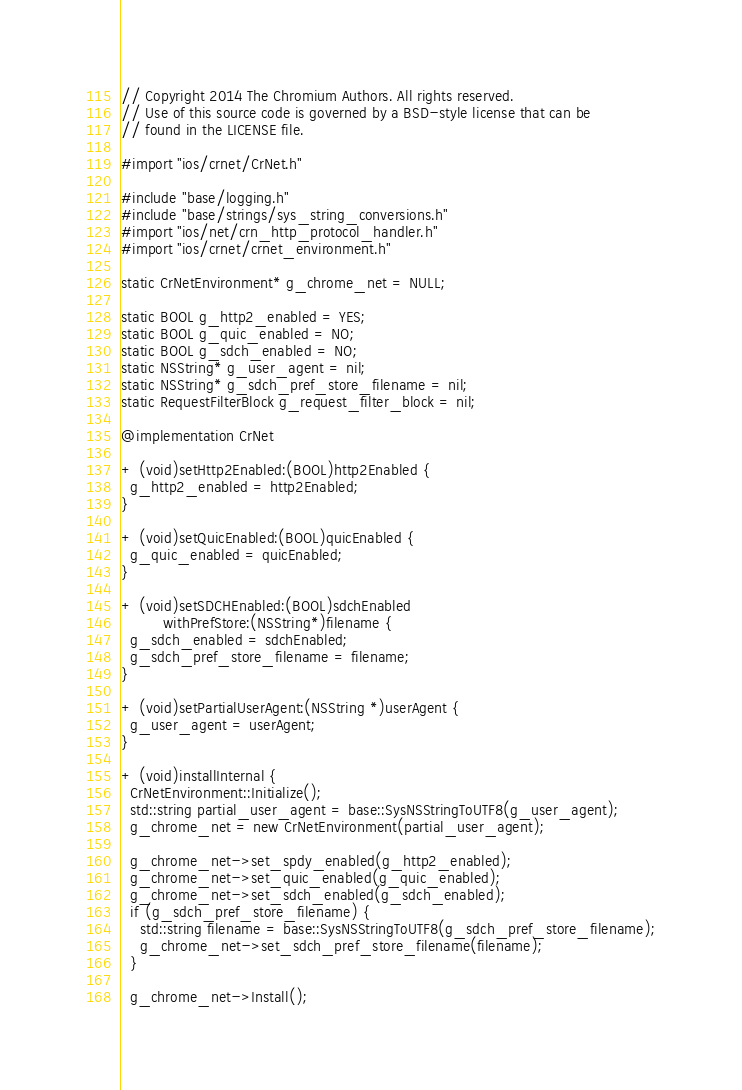Convert code to text. <code><loc_0><loc_0><loc_500><loc_500><_ObjectiveC_>// Copyright 2014 The Chromium Authors. All rights reserved.
// Use of this source code is governed by a BSD-style license that can be
// found in the LICENSE file.

#import "ios/crnet/CrNet.h"

#include "base/logging.h"
#include "base/strings/sys_string_conversions.h"
#import "ios/net/crn_http_protocol_handler.h"
#import "ios/crnet/crnet_environment.h"

static CrNetEnvironment* g_chrome_net = NULL;

static BOOL g_http2_enabled = YES;
static BOOL g_quic_enabled = NO;
static BOOL g_sdch_enabled = NO;
static NSString* g_user_agent = nil;
static NSString* g_sdch_pref_store_filename = nil;
static RequestFilterBlock g_request_filter_block = nil;

@implementation CrNet

+ (void)setHttp2Enabled:(BOOL)http2Enabled {
  g_http2_enabled = http2Enabled;
}

+ (void)setQuicEnabled:(BOOL)quicEnabled {
  g_quic_enabled = quicEnabled;
}

+ (void)setSDCHEnabled:(BOOL)sdchEnabled
         withPrefStore:(NSString*)filename {
  g_sdch_enabled = sdchEnabled;
  g_sdch_pref_store_filename = filename;
}

+ (void)setPartialUserAgent:(NSString *)userAgent {
  g_user_agent = userAgent;
}

+ (void)installInternal {
  CrNetEnvironment::Initialize();
  std::string partial_user_agent = base::SysNSStringToUTF8(g_user_agent);
  g_chrome_net = new CrNetEnvironment(partial_user_agent);

  g_chrome_net->set_spdy_enabled(g_http2_enabled);
  g_chrome_net->set_quic_enabled(g_quic_enabled);
  g_chrome_net->set_sdch_enabled(g_sdch_enabled);
  if (g_sdch_pref_store_filename) {
    std::string filename = base::SysNSStringToUTF8(g_sdch_pref_store_filename);
    g_chrome_net->set_sdch_pref_store_filename(filename);
  }

  g_chrome_net->Install();</code> 